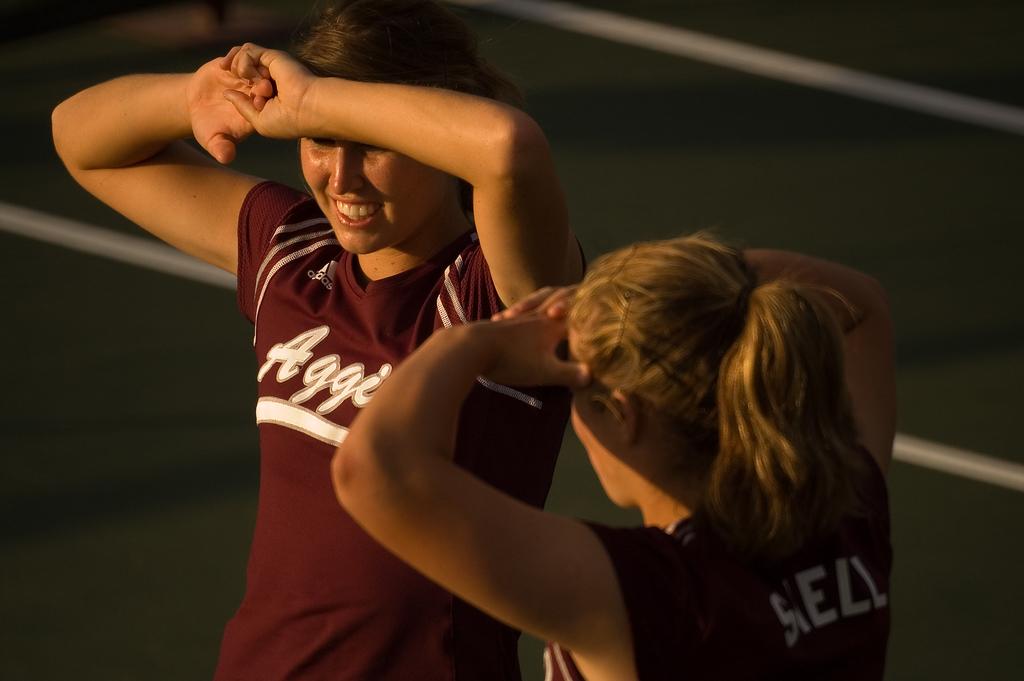What team is this?
Offer a terse response. Aggies. 